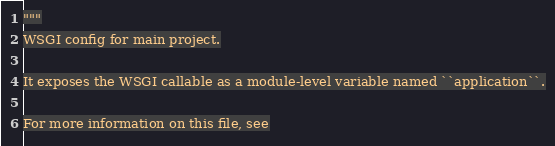Convert code to text. <code><loc_0><loc_0><loc_500><loc_500><_Python_>"""
WSGI config for main project.

It exposes the WSGI callable as a module-level variable named ``application``.

For more information on this file, see</code> 